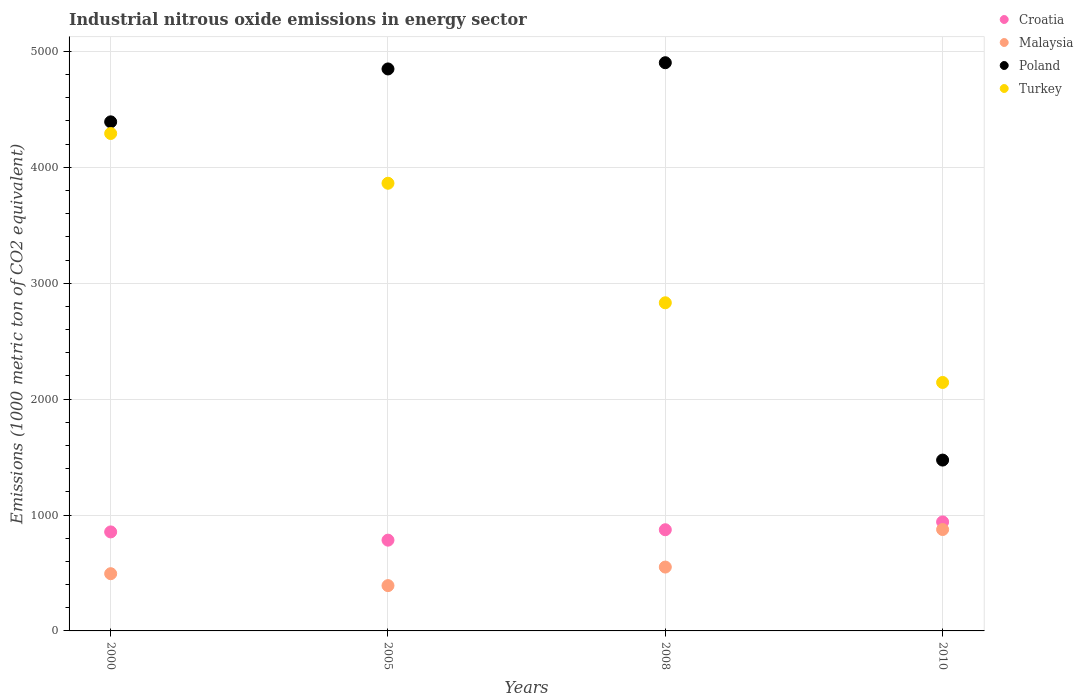How many different coloured dotlines are there?
Provide a short and direct response. 4. Is the number of dotlines equal to the number of legend labels?
Keep it short and to the point. Yes. What is the amount of industrial nitrous oxide emitted in Croatia in 2010?
Your answer should be compact. 940.6. Across all years, what is the maximum amount of industrial nitrous oxide emitted in Malaysia?
Offer a very short reply. 874.9. Across all years, what is the minimum amount of industrial nitrous oxide emitted in Croatia?
Your answer should be very brief. 783.2. In which year was the amount of industrial nitrous oxide emitted in Croatia maximum?
Ensure brevity in your answer.  2010. In which year was the amount of industrial nitrous oxide emitted in Poland minimum?
Offer a terse response. 2010. What is the total amount of industrial nitrous oxide emitted in Croatia in the graph?
Offer a terse response. 3451.1. What is the difference between the amount of industrial nitrous oxide emitted in Malaysia in 2008 and that in 2010?
Offer a very short reply. -323.9. What is the difference between the amount of industrial nitrous oxide emitted in Turkey in 2005 and the amount of industrial nitrous oxide emitted in Poland in 2008?
Make the answer very short. -1040. What is the average amount of industrial nitrous oxide emitted in Malaysia per year?
Your response must be concise. 577.65. In the year 2010, what is the difference between the amount of industrial nitrous oxide emitted in Croatia and amount of industrial nitrous oxide emitted in Turkey?
Offer a terse response. -1203.2. In how many years, is the amount of industrial nitrous oxide emitted in Croatia greater than 3800 1000 metric ton?
Offer a terse response. 0. What is the ratio of the amount of industrial nitrous oxide emitted in Poland in 2000 to that in 2008?
Offer a very short reply. 0.9. Is the amount of industrial nitrous oxide emitted in Turkey in 2000 less than that in 2008?
Ensure brevity in your answer.  No. Is the difference between the amount of industrial nitrous oxide emitted in Croatia in 2005 and 2010 greater than the difference between the amount of industrial nitrous oxide emitted in Turkey in 2005 and 2010?
Give a very brief answer. No. What is the difference between the highest and the second highest amount of industrial nitrous oxide emitted in Malaysia?
Offer a terse response. 323.9. What is the difference between the highest and the lowest amount of industrial nitrous oxide emitted in Malaysia?
Provide a succinct answer. 484. Is it the case that in every year, the sum of the amount of industrial nitrous oxide emitted in Croatia and amount of industrial nitrous oxide emitted in Turkey  is greater than the amount of industrial nitrous oxide emitted in Malaysia?
Offer a terse response. Yes. Is the amount of industrial nitrous oxide emitted in Poland strictly greater than the amount of industrial nitrous oxide emitted in Malaysia over the years?
Offer a terse response. Yes. What is the difference between two consecutive major ticks on the Y-axis?
Your answer should be very brief. 1000. Are the values on the major ticks of Y-axis written in scientific E-notation?
Offer a terse response. No. Does the graph contain any zero values?
Offer a terse response. No. What is the title of the graph?
Keep it short and to the point. Industrial nitrous oxide emissions in energy sector. Does "Burkina Faso" appear as one of the legend labels in the graph?
Your answer should be very brief. No. What is the label or title of the X-axis?
Your answer should be very brief. Years. What is the label or title of the Y-axis?
Provide a succinct answer. Emissions (1000 metric ton of CO2 equivalent). What is the Emissions (1000 metric ton of CO2 equivalent) in Croatia in 2000?
Give a very brief answer. 854.3. What is the Emissions (1000 metric ton of CO2 equivalent) of Malaysia in 2000?
Provide a short and direct response. 493.8. What is the Emissions (1000 metric ton of CO2 equivalent) in Poland in 2000?
Your answer should be compact. 4392.5. What is the Emissions (1000 metric ton of CO2 equivalent) of Turkey in 2000?
Make the answer very short. 4292. What is the Emissions (1000 metric ton of CO2 equivalent) in Croatia in 2005?
Make the answer very short. 783.2. What is the Emissions (1000 metric ton of CO2 equivalent) of Malaysia in 2005?
Keep it short and to the point. 390.9. What is the Emissions (1000 metric ton of CO2 equivalent) in Poland in 2005?
Your response must be concise. 4849. What is the Emissions (1000 metric ton of CO2 equivalent) of Turkey in 2005?
Your answer should be very brief. 3862.7. What is the Emissions (1000 metric ton of CO2 equivalent) of Croatia in 2008?
Ensure brevity in your answer.  873. What is the Emissions (1000 metric ton of CO2 equivalent) in Malaysia in 2008?
Make the answer very short. 551. What is the Emissions (1000 metric ton of CO2 equivalent) in Poland in 2008?
Offer a terse response. 4902.7. What is the Emissions (1000 metric ton of CO2 equivalent) in Turkey in 2008?
Keep it short and to the point. 2831.3. What is the Emissions (1000 metric ton of CO2 equivalent) in Croatia in 2010?
Give a very brief answer. 940.6. What is the Emissions (1000 metric ton of CO2 equivalent) in Malaysia in 2010?
Ensure brevity in your answer.  874.9. What is the Emissions (1000 metric ton of CO2 equivalent) of Poland in 2010?
Make the answer very short. 1474.1. What is the Emissions (1000 metric ton of CO2 equivalent) of Turkey in 2010?
Provide a succinct answer. 2143.8. Across all years, what is the maximum Emissions (1000 metric ton of CO2 equivalent) of Croatia?
Your answer should be compact. 940.6. Across all years, what is the maximum Emissions (1000 metric ton of CO2 equivalent) in Malaysia?
Make the answer very short. 874.9. Across all years, what is the maximum Emissions (1000 metric ton of CO2 equivalent) of Poland?
Offer a very short reply. 4902.7. Across all years, what is the maximum Emissions (1000 metric ton of CO2 equivalent) in Turkey?
Keep it short and to the point. 4292. Across all years, what is the minimum Emissions (1000 metric ton of CO2 equivalent) of Croatia?
Provide a short and direct response. 783.2. Across all years, what is the minimum Emissions (1000 metric ton of CO2 equivalent) of Malaysia?
Provide a short and direct response. 390.9. Across all years, what is the minimum Emissions (1000 metric ton of CO2 equivalent) of Poland?
Provide a short and direct response. 1474.1. Across all years, what is the minimum Emissions (1000 metric ton of CO2 equivalent) in Turkey?
Give a very brief answer. 2143.8. What is the total Emissions (1000 metric ton of CO2 equivalent) in Croatia in the graph?
Keep it short and to the point. 3451.1. What is the total Emissions (1000 metric ton of CO2 equivalent) of Malaysia in the graph?
Keep it short and to the point. 2310.6. What is the total Emissions (1000 metric ton of CO2 equivalent) of Poland in the graph?
Your response must be concise. 1.56e+04. What is the total Emissions (1000 metric ton of CO2 equivalent) of Turkey in the graph?
Ensure brevity in your answer.  1.31e+04. What is the difference between the Emissions (1000 metric ton of CO2 equivalent) in Croatia in 2000 and that in 2005?
Keep it short and to the point. 71.1. What is the difference between the Emissions (1000 metric ton of CO2 equivalent) in Malaysia in 2000 and that in 2005?
Offer a very short reply. 102.9. What is the difference between the Emissions (1000 metric ton of CO2 equivalent) in Poland in 2000 and that in 2005?
Your response must be concise. -456.5. What is the difference between the Emissions (1000 metric ton of CO2 equivalent) of Turkey in 2000 and that in 2005?
Your answer should be compact. 429.3. What is the difference between the Emissions (1000 metric ton of CO2 equivalent) in Croatia in 2000 and that in 2008?
Your response must be concise. -18.7. What is the difference between the Emissions (1000 metric ton of CO2 equivalent) of Malaysia in 2000 and that in 2008?
Your response must be concise. -57.2. What is the difference between the Emissions (1000 metric ton of CO2 equivalent) of Poland in 2000 and that in 2008?
Give a very brief answer. -510.2. What is the difference between the Emissions (1000 metric ton of CO2 equivalent) of Turkey in 2000 and that in 2008?
Your answer should be compact. 1460.7. What is the difference between the Emissions (1000 metric ton of CO2 equivalent) of Croatia in 2000 and that in 2010?
Give a very brief answer. -86.3. What is the difference between the Emissions (1000 metric ton of CO2 equivalent) of Malaysia in 2000 and that in 2010?
Your answer should be very brief. -381.1. What is the difference between the Emissions (1000 metric ton of CO2 equivalent) in Poland in 2000 and that in 2010?
Offer a very short reply. 2918.4. What is the difference between the Emissions (1000 metric ton of CO2 equivalent) in Turkey in 2000 and that in 2010?
Your answer should be very brief. 2148.2. What is the difference between the Emissions (1000 metric ton of CO2 equivalent) of Croatia in 2005 and that in 2008?
Give a very brief answer. -89.8. What is the difference between the Emissions (1000 metric ton of CO2 equivalent) of Malaysia in 2005 and that in 2008?
Your answer should be very brief. -160.1. What is the difference between the Emissions (1000 metric ton of CO2 equivalent) of Poland in 2005 and that in 2008?
Make the answer very short. -53.7. What is the difference between the Emissions (1000 metric ton of CO2 equivalent) of Turkey in 2005 and that in 2008?
Provide a short and direct response. 1031.4. What is the difference between the Emissions (1000 metric ton of CO2 equivalent) of Croatia in 2005 and that in 2010?
Offer a terse response. -157.4. What is the difference between the Emissions (1000 metric ton of CO2 equivalent) of Malaysia in 2005 and that in 2010?
Keep it short and to the point. -484. What is the difference between the Emissions (1000 metric ton of CO2 equivalent) in Poland in 2005 and that in 2010?
Offer a very short reply. 3374.9. What is the difference between the Emissions (1000 metric ton of CO2 equivalent) of Turkey in 2005 and that in 2010?
Ensure brevity in your answer.  1718.9. What is the difference between the Emissions (1000 metric ton of CO2 equivalent) of Croatia in 2008 and that in 2010?
Keep it short and to the point. -67.6. What is the difference between the Emissions (1000 metric ton of CO2 equivalent) of Malaysia in 2008 and that in 2010?
Your answer should be very brief. -323.9. What is the difference between the Emissions (1000 metric ton of CO2 equivalent) in Poland in 2008 and that in 2010?
Your response must be concise. 3428.6. What is the difference between the Emissions (1000 metric ton of CO2 equivalent) of Turkey in 2008 and that in 2010?
Ensure brevity in your answer.  687.5. What is the difference between the Emissions (1000 metric ton of CO2 equivalent) in Croatia in 2000 and the Emissions (1000 metric ton of CO2 equivalent) in Malaysia in 2005?
Ensure brevity in your answer.  463.4. What is the difference between the Emissions (1000 metric ton of CO2 equivalent) in Croatia in 2000 and the Emissions (1000 metric ton of CO2 equivalent) in Poland in 2005?
Your response must be concise. -3994.7. What is the difference between the Emissions (1000 metric ton of CO2 equivalent) in Croatia in 2000 and the Emissions (1000 metric ton of CO2 equivalent) in Turkey in 2005?
Make the answer very short. -3008.4. What is the difference between the Emissions (1000 metric ton of CO2 equivalent) in Malaysia in 2000 and the Emissions (1000 metric ton of CO2 equivalent) in Poland in 2005?
Offer a terse response. -4355.2. What is the difference between the Emissions (1000 metric ton of CO2 equivalent) of Malaysia in 2000 and the Emissions (1000 metric ton of CO2 equivalent) of Turkey in 2005?
Give a very brief answer. -3368.9. What is the difference between the Emissions (1000 metric ton of CO2 equivalent) in Poland in 2000 and the Emissions (1000 metric ton of CO2 equivalent) in Turkey in 2005?
Your answer should be compact. 529.8. What is the difference between the Emissions (1000 metric ton of CO2 equivalent) of Croatia in 2000 and the Emissions (1000 metric ton of CO2 equivalent) of Malaysia in 2008?
Ensure brevity in your answer.  303.3. What is the difference between the Emissions (1000 metric ton of CO2 equivalent) in Croatia in 2000 and the Emissions (1000 metric ton of CO2 equivalent) in Poland in 2008?
Provide a short and direct response. -4048.4. What is the difference between the Emissions (1000 metric ton of CO2 equivalent) in Croatia in 2000 and the Emissions (1000 metric ton of CO2 equivalent) in Turkey in 2008?
Your answer should be very brief. -1977. What is the difference between the Emissions (1000 metric ton of CO2 equivalent) of Malaysia in 2000 and the Emissions (1000 metric ton of CO2 equivalent) of Poland in 2008?
Ensure brevity in your answer.  -4408.9. What is the difference between the Emissions (1000 metric ton of CO2 equivalent) of Malaysia in 2000 and the Emissions (1000 metric ton of CO2 equivalent) of Turkey in 2008?
Give a very brief answer. -2337.5. What is the difference between the Emissions (1000 metric ton of CO2 equivalent) in Poland in 2000 and the Emissions (1000 metric ton of CO2 equivalent) in Turkey in 2008?
Your answer should be very brief. 1561.2. What is the difference between the Emissions (1000 metric ton of CO2 equivalent) in Croatia in 2000 and the Emissions (1000 metric ton of CO2 equivalent) in Malaysia in 2010?
Your answer should be very brief. -20.6. What is the difference between the Emissions (1000 metric ton of CO2 equivalent) of Croatia in 2000 and the Emissions (1000 metric ton of CO2 equivalent) of Poland in 2010?
Keep it short and to the point. -619.8. What is the difference between the Emissions (1000 metric ton of CO2 equivalent) in Croatia in 2000 and the Emissions (1000 metric ton of CO2 equivalent) in Turkey in 2010?
Offer a very short reply. -1289.5. What is the difference between the Emissions (1000 metric ton of CO2 equivalent) of Malaysia in 2000 and the Emissions (1000 metric ton of CO2 equivalent) of Poland in 2010?
Provide a succinct answer. -980.3. What is the difference between the Emissions (1000 metric ton of CO2 equivalent) of Malaysia in 2000 and the Emissions (1000 metric ton of CO2 equivalent) of Turkey in 2010?
Your answer should be very brief. -1650. What is the difference between the Emissions (1000 metric ton of CO2 equivalent) of Poland in 2000 and the Emissions (1000 metric ton of CO2 equivalent) of Turkey in 2010?
Ensure brevity in your answer.  2248.7. What is the difference between the Emissions (1000 metric ton of CO2 equivalent) in Croatia in 2005 and the Emissions (1000 metric ton of CO2 equivalent) in Malaysia in 2008?
Your response must be concise. 232.2. What is the difference between the Emissions (1000 metric ton of CO2 equivalent) in Croatia in 2005 and the Emissions (1000 metric ton of CO2 equivalent) in Poland in 2008?
Provide a short and direct response. -4119.5. What is the difference between the Emissions (1000 metric ton of CO2 equivalent) in Croatia in 2005 and the Emissions (1000 metric ton of CO2 equivalent) in Turkey in 2008?
Make the answer very short. -2048.1. What is the difference between the Emissions (1000 metric ton of CO2 equivalent) of Malaysia in 2005 and the Emissions (1000 metric ton of CO2 equivalent) of Poland in 2008?
Your response must be concise. -4511.8. What is the difference between the Emissions (1000 metric ton of CO2 equivalent) of Malaysia in 2005 and the Emissions (1000 metric ton of CO2 equivalent) of Turkey in 2008?
Give a very brief answer. -2440.4. What is the difference between the Emissions (1000 metric ton of CO2 equivalent) in Poland in 2005 and the Emissions (1000 metric ton of CO2 equivalent) in Turkey in 2008?
Keep it short and to the point. 2017.7. What is the difference between the Emissions (1000 metric ton of CO2 equivalent) of Croatia in 2005 and the Emissions (1000 metric ton of CO2 equivalent) of Malaysia in 2010?
Provide a succinct answer. -91.7. What is the difference between the Emissions (1000 metric ton of CO2 equivalent) of Croatia in 2005 and the Emissions (1000 metric ton of CO2 equivalent) of Poland in 2010?
Your answer should be compact. -690.9. What is the difference between the Emissions (1000 metric ton of CO2 equivalent) in Croatia in 2005 and the Emissions (1000 metric ton of CO2 equivalent) in Turkey in 2010?
Offer a very short reply. -1360.6. What is the difference between the Emissions (1000 metric ton of CO2 equivalent) in Malaysia in 2005 and the Emissions (1000 metric ton of CO2 equivalent) in Poland in 2010?
Your answer should be compact. -1083.2. What is the difference between the Emissions (1000 metric ton of CO2 equivalent) in Malaysia in 2005 and the Emissions (1000 metric ton of CO2 equivalent) in Turkey in 2010?
Offer a very short reply. -1752.9. What is the difference between the Emissions (1000 metric ton of CO2 equivalent) of Poland in 2005 and the Emissions (1000 metric ton of CO2 equivalent) of Turkey in 2010?
Your answer should be very brief. 2705.2. What is the difference between the Emissions (1000 metric ton of CO2 equivalent) of Croatia in 2008 and the Emissions (1000 metric ton of CO2 equivalent) of Poland in 2010?
Keep it short and to the point. -601.1. What is the difference between the Emissions (1000 metric ton of CO2 equivalent) of Croatia in 2008 and the Emissions (1000 metric ton of CO2 equivalent) of Turkey in 2010?
Offer a terse response. -1270.8. What is the difference between the Emissions (1000 metric ton of CO2 equivalent) in Malaysia in 2008 and the Emissions (1000 metric ton of CO2 equivalent) in Poland in 2010?
Give a very brief answer. -923.1. What is the difference between the Emissions (1000 metric ton of CO2 equivalent) of Malaysia in 2008 and the Emissions (1000 metric ton of CO2 equivalent) of Turkey in 2010?
Make the answer very short. -1592.8. What is the difference between the Emissions (1000 metric ton of CO2 equivalent) in Poland in 2008 and the Emissions (1000 metric ton of CO2 equivalent) in Turkey in 2010?
Ensure brevity in your answer.  2758.9. What is the average Emissions (1000 metric ton of CO2 equivalent) of Croatia per year?
Your answer should be compact. 862.77. What is the average Emissions (1000 metric ton of CO2 equivalent) of Malaysia per year?
Provide a succinct answer. 577.65. What is the average Emissions (1000 metric ton of CO2 equivalent) in Poland per year?
Keep it short and to the point. 3904.57. What is the average Emissions (1000 metric ton of CO2 equivalent) of Turkey per year?
Provide a succinct answer. 3282.45. In the year 2000, what is the difference between the Emissions (1000 metric ton of CO2 equivalent) of Croatia and Emissions (1000 metric ton of CO2 equivalent) of Malaysia?
Offer a terse response. 360.5. In the year 2000, what is the difference between the Emissions (1000 metric ton of CO2 equivalent) of Croatia and Emissions (1000 metric ton of CO2 equivalent) of Poland?
Your response must be concise. -3538.2. In the year 2000, what is the difference between the Emissions (1000 metric ton of CO2 equivalent) of Croatia and Emissions (1000 metric ton of CO2 equivalent) of Turkey?
Offer a terse response. -3437.7. In the year 2000, what is the difference between the Emissions (1000 metric ton of CO2 equivalent) in Malaysia and Emissions (1000 metric ton of CO2 equivalent) in Poland?
Ensure brevity in your answer.  -3898.7. In the year 2000, what is the difference between the Emissions (1000 metric ton of CO2 equivalent) of Malaysia and Emissions (1000 metric ton of CO2 equivalent) of Turkey?
Offer a very short reply. -3798.2. In the year 2000, what is the difference between the Emissions (1000 metric ton of CO2 equivalent) in Poland and Emissions (1000 metric ton of CO2 equivalent) in Turkey?
Offer a very short reply. 100.5. In the year 2005, what is the difference between the Emissions (1000 metric ton of CO2 equivalent) of Croatia and Emissions (1000 metric ton of CO2 equivalent) of Malaysia?
Provide a succinct answer. 392.3. In the year 2005, what is the difference between the Emissions (1000 metric ton of CO2 equivalent) of Croatia and Emissions (1000 metric ton of CO2 equivalent) of Poland?
Provide a succinct answer. -4065.8. In the year 2005, what is the difference between the Emissions (1000 metric ton of CO2 equivalent) in Croatia and Emissions (1000 metric ton of CO2 equivalent) in Turkey?
Your response must be concise. -3079.5. In the year 2005, what is the difference between the Emissions (1000 metric ton of CO2 equivalent) of Malaysia and Emissions (1000 metric ton of CO2 equivalent) of Poland?
Offer a very short reply. -4458.1. In the year 2005, what is the difference between the Emissions (1000 metric ton of CO2 equivalent) of Malaysia and Emissions (1000 metric ton of CO2 equivalent) of Turkey?
Provide a succinct answer. -3471.8. In the year 2005, what is the difference between the Emissions (1000 metric ton of CO2 equivalent) of Poland and Emissions (1000 metric ton of CO2 equivalent) of Turkey?
Make the answer very short. 986.3. In the year 2008, what is the difference between the Emissions (1000 metric ton of CO2 equivalent) of Croatia and Emissions (1000 metric ton of CO2 equivalent) of Malaysia?
Your answer should be very brief. 322. In the year 2008, what is the difference between the Emissions (1000 metric ton of CO2 equivalent) in Croatia and Emissions (1000 metric ton of CO2 equivalent) in Poland?
Your answer should be very brief. -4029.7. In the year 2008, what is the difference between the Emissions (1000 metric ton of CO2 equivalent) in Croatia and Emissions (1000 metric ton of CO2 equivalent) in Turkey?
Your answer should be very brief. -1958.3. In the year 2008, what is the difference between the Emissions (1000 metric ton of CO2 equivalent) in Malaysia and Emissions (1000 metric ton of CO2 equivalent) in Poland?
Provide a succinct answer. -4351.7. In the year 2008, what is the difference between the Emissions (1000 metric ton of CO2 equivalent) of Malaysia and Emissions (1000 metric ton of CO2 equivalent) of Turkey?
Make the answer very short. -2280.3. In the year 2008, what is the difference between the Emissions (1000 metric ton of CO2 equivalent) in Poland and Emissions (1000 metric ton of CO2 equivalent) in Turkey?
Your answer should be compact. 2071.4. In the year 2010, what is the difference between the Emissions (1000 metric ton of CO2 equivalent) of Croatia and Emissions (1000 metric ton of CO2 equivalent) of Malaysia?
Keep it short and to the point. 65.7. In the year 2010, what is the difference between the Emissions (1000 metric ton of CO2 equivalent) of Croatia and Emissions (1000 metric ton of CO2 equivalent) of Poland?
Give a very brief answer. -533.5. In the year 2010, what is the difference between the Emissions (1000 metric ton of CO2 equivalent) in Croatia and Emissions (1000 metric ton of CO2 equivalent) in Turkey?
Your response must be concise. -1203.2. In the year 2010, what is the difference between the Emissions (1000 metric ton of CO2 equivalent) in Malaysia and Emissions (1000 metric ton of CO2 equivalent) in Poland?
Your answer should be very brief. -599.2. In the year 2010, what is the difference between the Emissions (1000 metric ton of CO2 equivalent) of Malaysia and Emissions (1000 metric ton of CO2 equivalent) of Turkey?
Your response must be concise. -1268.9. In the year 2010, what is the difference between the Emissions (1000 metric ton of CO2 equivalent) in Poland and Emissions (1000 metric ton of CO2 equivalent) in Turkey?
Your answer should be very brief. -669.7. What is the ratio of the Emissions (1000 metric ton of CO2 equivalent) in Croatia in 2000 to that in 2005?
Provide a short and direct response. 1.09. What is the ratio of the Emissions (1000 metric ton of CO2 equivalent) of Malaysia in 2000 to that in 2005?
Offer a terse response. 1.26. What is the ratio of the Emissions (1000 metric ton of CO2 equivalent) of Poland in 2000 to that in 2005?
Your response must be concise. 0.91. What is the ratio of the Emissions (1000 metric ton of CO2 equivalent) of Croatia in 2000 to that in 2008?
Ensure brevity in your answer.  0.98. What is the ratio of the Emissions (1000 metric ton of CO2 equivalent) in Malaysia in 2000 to that in 2008?
Your response must be concise. 0.9. What is the ratio of the Emissions (1000 metric ton of CO2 equivalent) of Poland in 2000 to that in 2008?
Ensure brevity in your answer.  0.9. What is the ratio of the Emissions (1000 metric ton of CO2 equivalent) of Turkey in 2000 to that in 2008?
Your answer should be compact. 1.52. What is the ratio of the Emissions (1000 metric ton of CO2 equivalent) in Croatia in 2000 to that in 2010?
Your answer should be very brief. 0.91. What is the ratio of the Emissions (1000 metric ton of CO2 equivalent) of Malaysia in 2000 to that in 2010?
Keep it short and to the point. 0.56. What is the ratio of the Emissions (1000 metric ton of CO2 equivalent) in Poland in 2000 to that in 2010?
Your answer should be compact. 2.98. What is the ratio of the Emissions (1000 metric ton of CO2 equivalent) in Turkey in 2000 to that in 2010?
Your response must be concise. 2. What is the ratio of the Emissions (1000 metric ton of CO2 equivalent) of Croatia in 2005 to that in 2008?
Provide a succinct answer. 0.9. What is the ratio of the Emissions (1000 metric ton of CO2 equivalent) in Malaysia in 2005 to that in 2008?
Give a very brief answer. 0.71. What is the ratio of the Emissions (1000 metric ton of CO2 equivalent) of Poland in 2005 to that in 2008?
Keep it short and to the point. 0.99. What is the ratio of the Emissions (1000 metric ton of CO2 equivalent) of Turkey in 2005 to that in 2008?
Provide a succinct answer. 1.36. What is the ratio of the Emissions (1000 metric ton of CO2 equivalent) of Croatia in 2005 to that in 2010?
Your answer should be very brief. 0.83. What is the ratio of the Emissions (1000 metric ton of CO2 equivalent) in Malaysia in 2005 to that in 2010?
Keep it short and to the point. 0.45. What is the ratio of the Emissions (1000 metric ton of CO2 equivalent) of Poland in 2005 to that in 2010?
Ensure brevity in your answer.  3.29. What is the ratio of the Emissions (1000 metric ton of CO2 equivalent) in Turkey in 2005 to that in 2010?
Ensure brevity in your answer.  1.8. What is the ratio of the Emissions (1000 metric ton of CO2 equivalent) of Croatia in 2008 to that in 2010?
Provide a short and direct response. 0.93. What is the ratio of the Emissions (1000 metric ton of CO2 equivalent) in Malaysia in 2008 to that in 2010?
Offer a very short reply. 0.63. What is the ratio of the Emissions (1000 metric ton of CO2 equivalent) of Poland in 2008 to that in 2010?
Your response must be concise. 3.33. What is the ratio of the Emissions (1000 metric ton of CO2 equivalent) of Turkey in 2008 to that in 2010?
Your answer should be very brief. 1.32. What is the difference between the highest and the second highest Emissions (1000 metric ton of CO2 equivalent) in Croatia?
Ensure brevity in your answer.  67.6. What is the difference between the highest and the second highest Emissions (1000 metric ton of CO2 equivalent) in Malaysia?
Provide a short and direct response. 323.9. What is the difference between the highest and the second highest Emissions (1000 metric ton of CO2 equivalent) of Poland?
Offer a terse response. 53.7. What is the difference between the highest and the second highest Emissions (1000 metric ton of CO2 equivalent) of Turkey?
Provide a short and direct response. 429.3. What is the difference between the highest and the lowest Emissions (1000 metric ton of CO2 equivalent) in Croatia?
Keep it short and to the point. 157.4. What is the difference between the highest and the lowest Emissions (1000 metric ton of CO2 equivalent) of Malaysia?
Make the answer very short. 484. What is the difference between the highest and the lowest Emissions (1000 metric ton of CO2 equivalent) of Poland?
Your answer should be compact. 3428.6. What is the difference between the highest and the lowest Emissions (1000 metric ton of CO2 equivalent) of Turkey?
Give a very brief answer. 2148.2. 